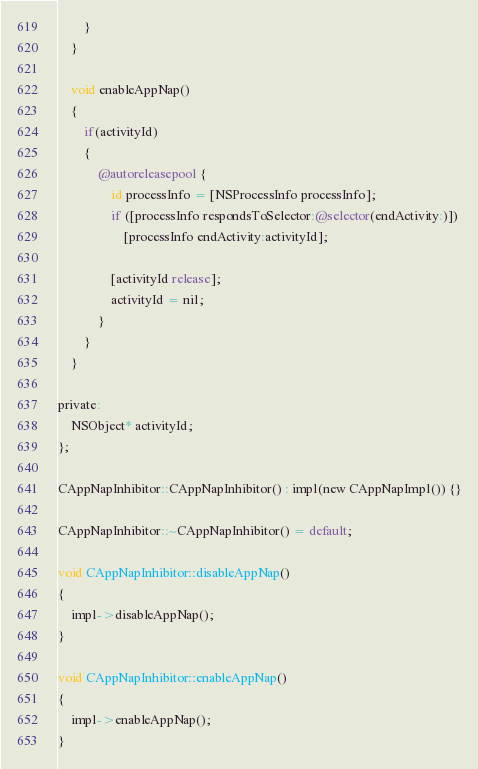<code> <loc_0><loc_0><loc_500><loc_500><_ObjectiveC_>        }
    }

    void enableAppNap()
    {
        if(activityId)
        {
            @autoreleasepool {
                id processInfo = [NSProcessInfo processInfo];
                if ([processInfo respondsToSelector:@selector(endActivity:)])
                    [processInfo endActivity:activityId];

                [activityId release];
                activityId = nil;
            }
        }
    }

private:
    NSObject* activityId;
};

CAppNapInhibitor::CAppNapInhibitor() : impl(new CAppNapImpl()) {}

CAppNapInhibitor::~CAppNapInhibitor() = default;

void CAppNapInhibitor::disableAppNap()
{
    impl->disableAppNap();
}

void CAppNapInhibitor::enableAppNap()
{
    impl->enableAppNap();
}
</code> 